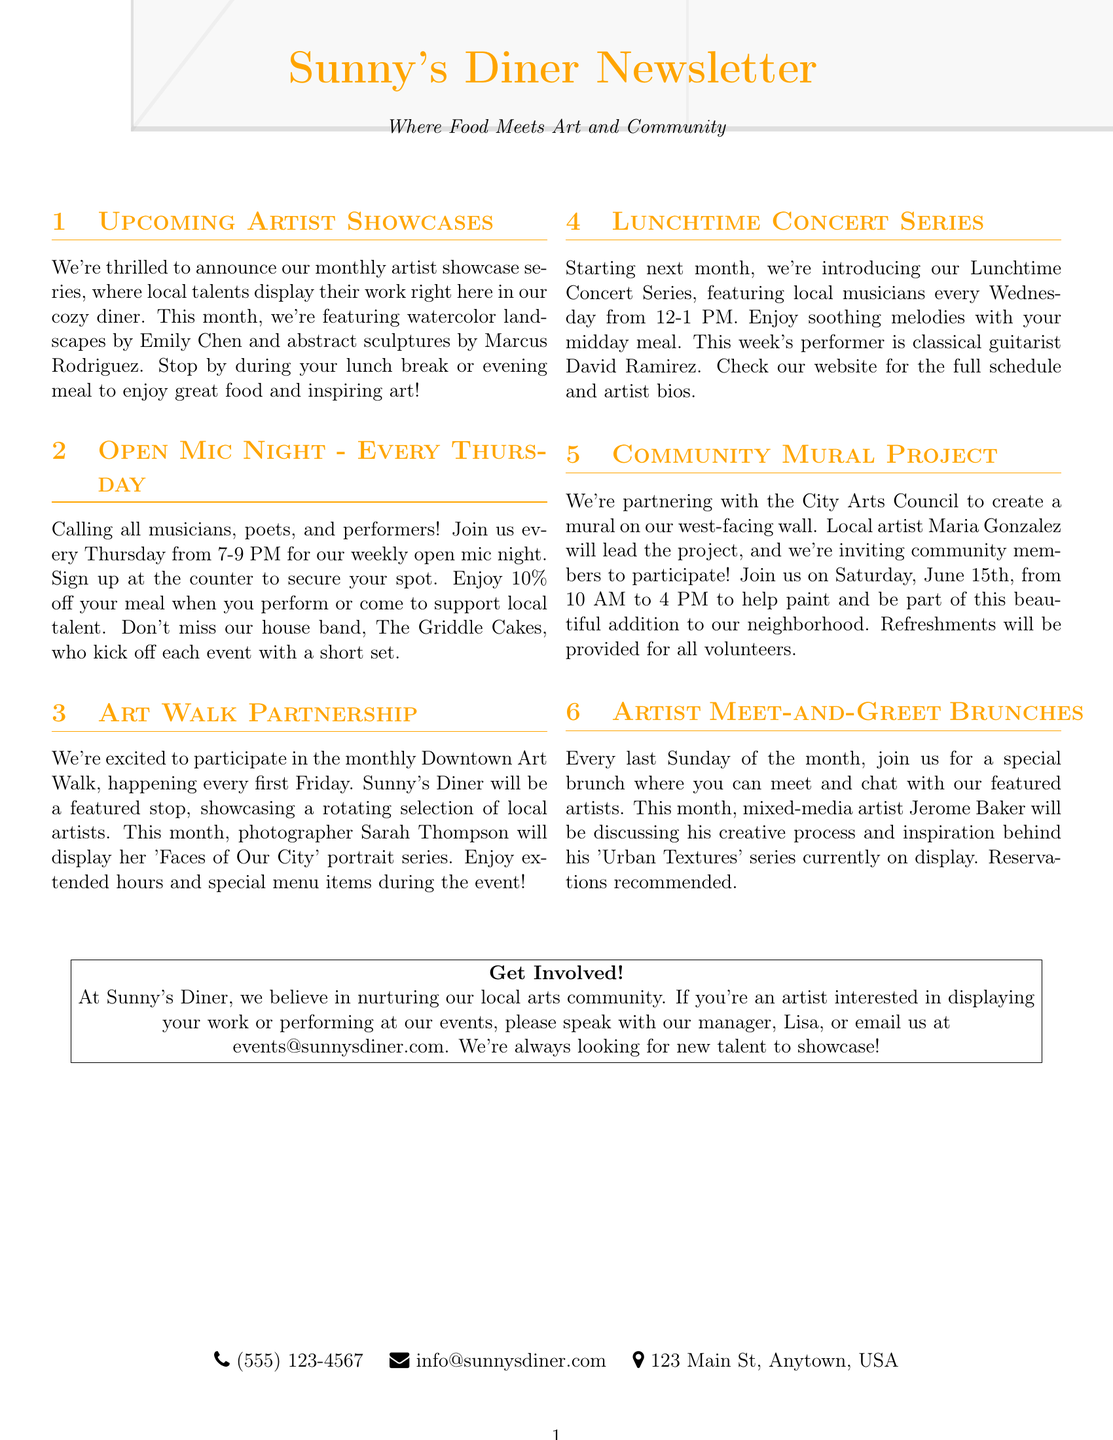What artists are showcased this month? The document lists Emily Chen and Marcus Rodriguez as the featured artists this month.
Answer: Emily Chen and Marcus Rodriguez When does the Open Mic Night take place? The Open Mic Night is held every Thursday from 7-9 PM.
Answer: Every Thursday from 7-9 PM What series is featured during the Lunchtime Concert Series this week? This week's performer is classical guitarist David Ramirez.
Answer: Classical guitarist David Ramirez What is the date for the Community Mural Project event? The event will take place on Saturday, June 15th.
Answer: Saturday, June 15th Who can participate in the Community Mural Project? Community members are invited to participate in the mural project.
Answer: Community members How often do the Artist Meet-and-Greet Brunches occur? The brunches are held every last Sunday of the month.
Answer: Every last Sunday of the month What is provided for volunteers during the Community Mural Project? Refreshments will be provided for all volunteers.
Answer: Refreshments What is the email address for artists interested in showcasing their work? Artists can email events@sunnysdiner.com to express their interest.
Answer: events@sunnysdiner.com 